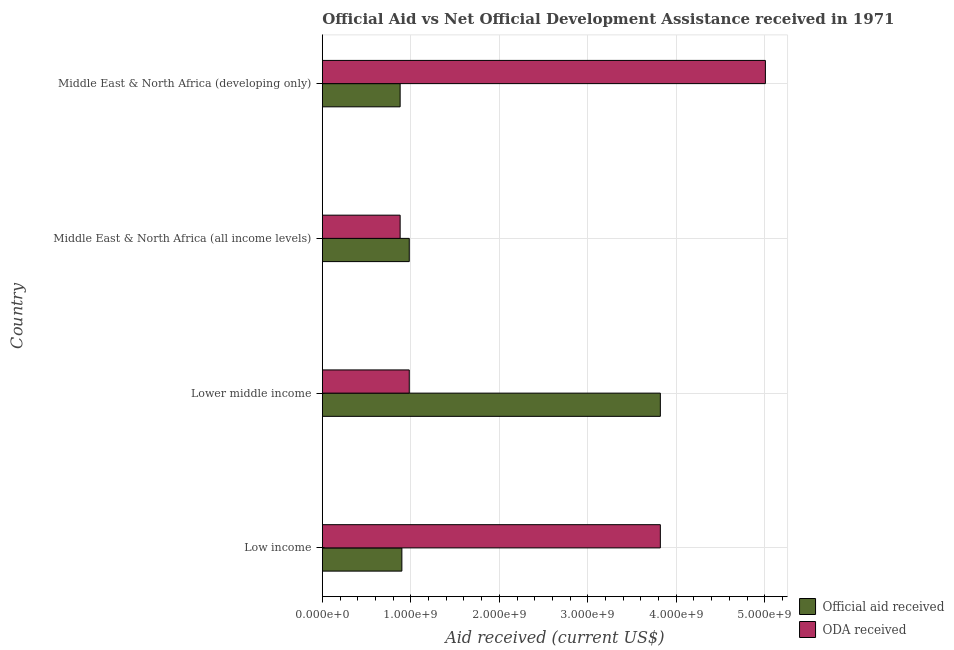How many different coloured bars are there?
Offer a very short reply. 2. How many groups of bars are there?
Offer a very short reply. 4. Are the number of bars per tick equal to the number of legend labels?
Make the answer very short. Yes. How many bars are there on the 1st tick from the bottom?
Your response must be concise. 2. What is the label of the 1st group of bars from the top?
Offer a very short reply. Middle East & North Africa (developing only). In how many cases, is the number of bars for a given country not equal to the number of legend labels?
Your response must be concise. 0. What is the oda received in Middle East & North Africa (all income levels)?
Make the answer very short. 8.79e+08. Across all countries, what is the maximum official aid received?
Your answer should be very brief. 3.82e+09. Across all countries, what is the minimum oda received?
Keep it short and to the point. 8.79e+08. In which country was the official aid received maximum?
Offer a very short reply. Lower middle income. In which country was the official aid received minimum?
Make the answer very short. Middle East & North Africa (developing only). What is the total oda received in the graph?
Your answer should be very brief. 1.07e+1. What is the difference between the official aid received in Low income and that in Middle East & North Africa (developing only)?
Your answer should be very brief. 1.96e+07. What is the difference between the oda received in Lower middle income and the official aid received in Middle East & North Africa (developing only)?
Make the answer very short. 1.03e+08. What is the average official aid received per country?
Provide a succinct answer. 1.65e+09. What is the difference between the oda received and official aid received in Middle East & North Africa (all income levels)?
Provide a short and direct response. -1.03e+08. In how many countries, is the official aid received greater than 4600000000 US$?
Give a very brief answer. 0. What is the ratio of the oda received in Lower middle income to that in Middle East & North Africa (all income levels)?
Make the answer very short. 1.12. Is the official aid received in Low income less than that in Middle East & North Africa (all income levels)?
Provide a succinct answer. Yes. Is the difference between the oda received in Lower middle income and Middle East & North Africa (all income levels) greater than the difference between the official aid received in Lower middle income and Middle East & North Africa (all income levels)?
Offer a very short reply. No. What is the difference between the highest and the second highest oda received?
Offer a terse response. 1.19e+09. What is the difference between the highest and the lowest oda received?
Ensure brevity in your answer.  4.13e+09. In how many countries, is the oda received greater than the average oda received taken over all countries?
Your response must be concise. 2. Is the sum of the official aid received in Low income and Middle East & North Africa (developing only) greater than the maximum oda received across all countries?
Provide a short and direct response. No. What does the 2nd bar from the top in Middle East & North Africa (all income levels) represents?
Your answer should be compact. Official aid received. What does the 1st bar from the bottom in Lower middle income represents?
Give a very brief answer. Official aid received. Are the values on the major ticks of X-axis written in scientific E-notation?
Ensure brevity in your answer.  Yes. Does the graph contain any zero values?
Make the answer very short. No. Does the graph contain grids?
Keep it short and to the point. Yes. Where does the legend appear in the graph?
Offer a terse response. Bottom right. How are the legend labels stacked?
Offer a very short reply. Vertical. What is the title of the graph?
Offer a terse response. Official Aid vs Net Official Development Assistance received in 1971 . What is the label or title of the X-axis?
Give a very brief answer. Aid received (current US$). What is the Aid received (current US$) in Official aid received in Low income?
Offer a terse response. 8.99e+08. What is the Aid received (current US$) of ODA received in Low income?
Provide a succinct answer. 3.82e+09. What is the Aid received (current US$) of Official aid received in Lower middle income?
Your answer should be very brief. 3.82e+09. What is the Aid received (current US$) of ODA received in Lower middle income?
Provide a short and direct response. 9.83e+08. What is the Aid received (current US$) of Official aid received in Middle East & North Africa (all income levels)?
Offer a very short reply. 9.83e+08. What is the Aid received (current US$) of ODA received in Middle East & North Africa (all income levels)?
Ensure brevity in your answer.  8.79e+08. What is the Aid received (current US$) of Official aid received in Middle East & North Africa (developing only)?
Ensure brevity in your answer.  8.79e+08. What is the Aid received (current US$) in ODA received in Middle East & North Africa (developing only)?
Your answer should be very brief. 5.01e+09. Across all countries, what is the maximum Aid received (current US$) in Official aid received?
Your response must be concise. 3.82e+09. Across all countries, what is the maximum Aid received (current US$) of ODA received?
Your answer should be compact. 5.01e+09. Across all countries, what is the minimum Aid received (current US$) of Official aid received?
Your response must be concise. 8.79e+08. Across all countries, what is the minimum Aid received (current US$) of ODA received?
Keep it short and to the point. 8.79e+08. What is the total Aid received (current US$) of Official aid received in the graph?
Ensure brevity in your answer.  6.58e+09. What is the total Aid received (current US$) in ODA received in the graph?
Your answer should be compact. 1.07e+1. What is the difference between the Aid received (current US$) of Official aid received in Low income and that in Lower middle income?
Keep it short and to the point. -2.92e+09. What is the difference between the Aid received (current US$) in ODA received in Low income and that in Lower middle income?
Your answer should be very brief. 2.84e+09. What is the difference between the Aid received (current US$) in Official aid received in Low income and that in Middle East & North Africa (all income levels)?
Provide a short and direct response. -8.36e+07. What is the difference between the Aid received (current US$) of ODA received in Low income and that in Middle East & North Africa (all income levels)?
Give a very brief answer. 2.94e+09. What is the difference between the Aid received (current US$) in Official aid received in Low income and that in Middle East & North Africa (developing only)?
Offer a terse response. 1.96e+07. What is the difference between the Aid received (current US$) of ODA received in Low income and that in Middle East & North Africa (developing only)?
Offer a very short reply. -1.19e+09. What is the difference between the Aid received (current US$) of Official aid received in Lower middle income and that in Middle East & North Africa (all income levels)?
Make the answer very short. 2.84e+09. What is the difference between the Aid received (current US$) of ODA received in Lower middle income and that in Middle East & North Africa (all income levels)?
Offer a terse response. 1.03e+08. What is the difference between the Aid received (current US$) of Official aid received in Lower middle income and that in Middle East & North Africa (developing only)?
Your answer should be very brief. 2.94e+09. What is the difference between the Aid received (current US$) of ODA received in Lower middle income and that in Middle East & North Africa (developing only)?
Offer a terse response. -4.02e+09. What is the difference between the Aid received (current US$) in Official aid received in Middle East & North Africa (all income levels) and that in Middle East & North Africa (developing only)?
Make the answer very short. 1.03e+08. What is the difference between the Aid received (current US$) of ODA received in Middle East & North Africa (all income levels) and that in Middle East & North Africa (developing only)?
Keep it short and to the point. -4.13e+09. What is the difference between the Aid received (current US$) in Official aid received in Low income and the Aid received (current US$) in ODA received in Lower middle income?
Make the answer very short. -8.36e+07. What is the difference between the Aid received (current US$) of Official aid received in Low income and the Aid received (current US$) of ODA received in Middle East & North Africa (all income levels)?
Keep it short and to the point. 1.96e+07. What is the difference between the Aid received (current US$) of Official aid received in Low income and the Aid received (current US$) of ODA received in Middle East & North Africa (developing only)?
Your answer should be very brief. -4.11e+09. What is the difference between the Aid received (current US$) of Official aid received in Lower middle income and the Aid received (current US$) of ODA received in Middle East & North Africa (all income levels)?
Your answer should be very brief. 2.94e+09. What is the difference between the Aid received (current US$) of Official aid received in Lower middle income and the Aid received (current US$) of ODA received in Middle East & North Africa (developing only)?
Make the answer very short. -1.19e+09. What is the difference between the Aid received (current US$) of Official aid received in Middle East & North Africa (all income levels) and the Aid received (current US$) of ODA received in Middle East & North Africa (developing only)?
Provide a succinct answer. -4.02e+09. What is the average Aid received (current US$) in Official aid received per country?
Your response must be concise. 1.65e+09. What is the average Aid received (current US$) of ODA received per country?
Ensure brevity in your answer.  2.67e+09. What is the difference between the Aid received (current US$) in Official aid received and Aid received (current US$) in ODA received in Low income?
Provide a succinct answer. -2.92e+09. What is the difference between the Aid received (current US$) in Official aid received and Aid received (current US$) in ODA received in Lower middle income?
Provide a short and direct response. 2.84e+09. What is the difference between the Aid received (current US$) of Official aid received and Aid received (current US$) of ODA received in Middle East & North Africa (all income levels)?
Make the answer very short. 1.03e+08. What is the difference between the Aid received (current US$) of Official aid received and Aid received (current US$) of ODA received in Middle East & North Africa (developing only)?
Provide a short and direct response. -4.13e+09. What is the ratio of the Aid received (current US$) in Official aid received in Low income to that in Lower middle income?
Provide a short and direct response. 0.24. What is the ratio of the Aid received (current US$) in ODA received in Low income to that in Lower middle income?
Your response must be concise. 3.89. What is the ratio of the Aid received (current US$) of Official aid received in Low income to that in Middle East & North Africa (all income levels)?
Keep it short and to the point. 0.92. What is the ratio of the Aid received (current US$) in ODA received in Low income to that in Middle East & North Africa (all income levels)?
Offer a terse response. 4.34. What is the ratio of the Aid received (current US$) in Official aid received in Low income to that in Middle East & North Africa (developing only)?
Provide a succinct answer. 1.02. What is the ratio of the Aid received (current US$) in ODA received in Low income to that in Middle East & North Africa (developing only)?
Provide a succinct answer. 0.76. What is the ratio of the Aid received (current US$) of Official aid received in Lower middle income to that in Middle East & North Africa (all income levels)?
Ensure brevity in your answer.  3.89. What is the ratio of the Aid received (current US$) in ODA received in Lower middle income to that in Middle East & North Africa (all income levels)?
Ensure brevity in your answer.  1.12. What is the ratio of the Aid received (current US$) of Official aid received in Lower middle income to that in Middle East & North Africa (developing only)?
Ensure brevity in your answer.  4.34. What is the ratio of the Aid received (current US$) of ODA received in Lower middle income to that in Middle East & North Africa (developing only)?
Your response must be concise. 0.2. What is the ratio of the Aid received (current US$) in Official aid received in Middle East & North Africa (all income levels) to that in Middle East & North Africa (developing only)?
Give a very brief answer. 1.12. What is the ratio of the Aid received (current US$) of ODA received in Middle East & North Africa (all income levels) to that in Middle East & North Africa (developing only)?
Keep it short and to the point. 0.18. What is the difference between the highest and the second highest Aid received (current US$) in Official aid received?
Offer a terse response. 2.84e+09. What is the difference between the highest and the second highest Aid received (current US$) in ODA received?
Offer a very short reply. 1.19e+09. What is the difference between the highest and the lowest Aid received (current US$) in Official aid received?
Offer a very short reply. 2.94e+09. What is the difference between the highest and the lowest Aid received (current US$) in ODA received?
Offer a very short reply. 4.13e+09. 